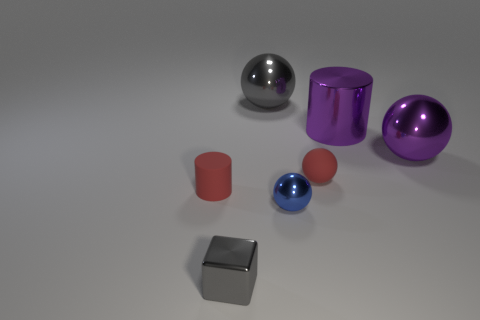How many other objects are the same shape as the tiny blue thing?
Offer a terse response. 3. There is a object that is left of the tiny matte sphere and behind the tiny red matte ball; what is its material?
Your response must be concise. Metal. How many objects are rubber spheres or big purple metallic balls?
Make the answer very short. 2. Is the number of small cyan spheres greater than the number of tiny objects?
Make the answer very short. No. There is a object that is to the left of the gray object that is in front of the big gray ball; what size is it?
Give a very brief answer. Small. What is the color of the other tiny object that is the same shape as the blue metallic object?
Your answer should be compact. Red. The purple metal sphere has what size?
Your response must be concise. Large. What number of blocks are either large gray objects or metal things?
Your response must be concise. 1. There is a purple object that is the same shape as the tiny blue object; what size is it?
Provide a succinct answer. Large. How many large yellow metallic cubes are there?
Offer a terse response. 0. 